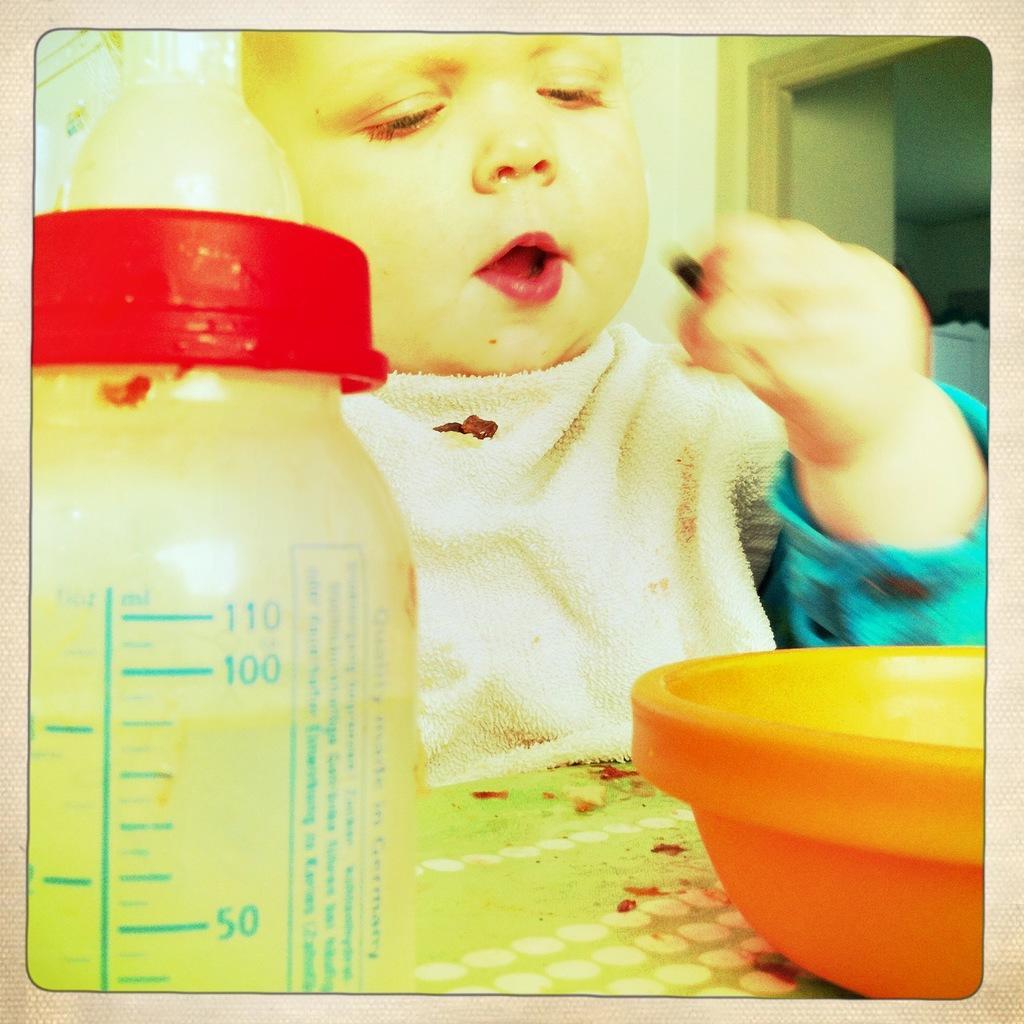Please provide a concise description of this image. The kid is sitting in front of a table and there is a bowl and milk bottle in front of him. 